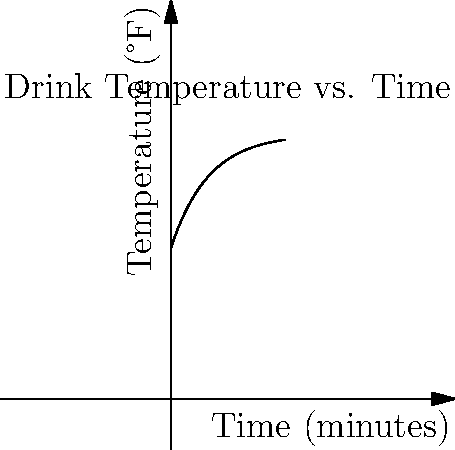As a wedding planner, you're testing a new signature cocktail. The graph shows the temperature of the drink over time as it warms up from its initial chilled state. If the drink's temperature $T$ (in °F) at time $t$ (in minutes) is given by the function $T(t) = 70 - 30e^{-0.1t}$, at what rate is the drink's temperature increasing after 10 minutes? To find the rate at which the drink's temperature is increasing after 10 minutes, we need to calculate the derivative of the temperature function at t = 10.

Step 1: Find the derivative of the temperature function.
$T(t) = 70 - 30e^{-0.1t}$
$\frac{dT}{dt} = -30 \cdot (-0.1e^{-0.1t}) = 3e^{-0.1t}$

Step 2: Evaluate the derivative at t = 10.
$\frac{dT}{dt}|_{t=10} = 3e^{-0.1(10)} = 3e^{-1} \approx 1.10$

Step 3: Interpret the result.
The rate of change at t = 10 minutes is approximately 1.10 °F per minute.
Answer: 1.10 °F/min 